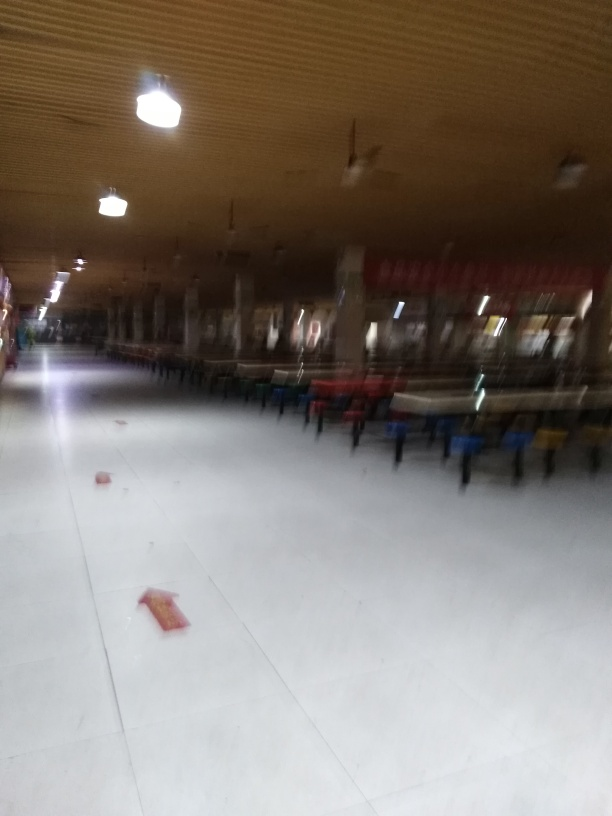Is there anything on the floor? Yes, there are a few objects scattered on the floor that appear to be bricks or blocks of some sort. These objects seem out of place and may indicate recent activity or ongoing work in the area. 